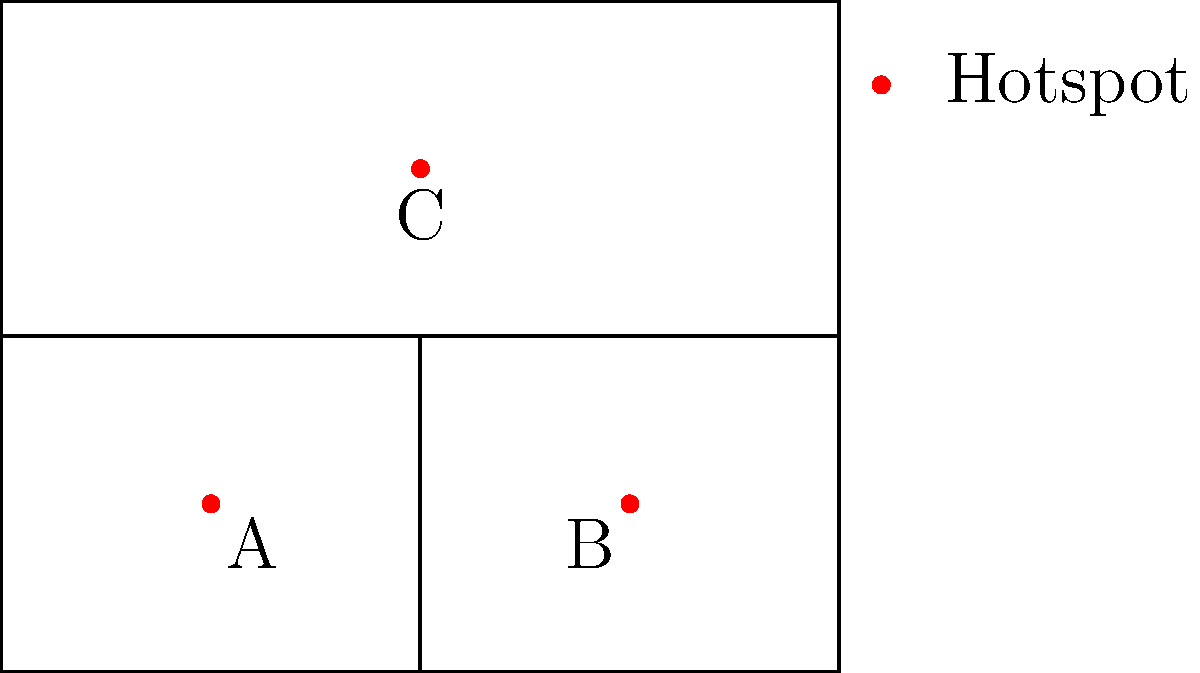Based on the floor plan of a haunted location with marked hotspots, which room contains the most paranormal activity hotspots, and what strategy would you recommend for investigating this area? To answer this question, let's analyze the floor plan step-by-step:

1. The floor plan shows three distinct rooms:
   - Room 1: Bottom left
   - Room 2: Bottom right
   - Room 3: Entire top half

2. Hotspots are marked with red dots and labeled A, B, and C.

3. Counting hotspots in each room:
   - Room 1: 1 hotspot (A)
   - Room 2: 1 hotspot (B)
   - Room 3: 1 hotspot (C)

4. Room 3 is the largest and contains the same number of hotspots as the other rooms, making it the most significant area for investigation.

5. Strategy for investigating Room 3:
   a) Start with a thorough baseline sweep of the entire room.
   b) Focus on the area around hotspot C, as it's centrally located.
   c) Use EMF meters, infrared cameras, and audio recorders to capture potential paranormal activity.
   d) Conduct EVP (Electronic Voice Phenomenon) sessions near hotspot C.
   e) Set up static cameras to monitor the entire room, with emphasis on the hotspot area.
   f) Periodically check the other rooms' hotspots (A and B) for any connected activity.

This strategy allows for a comprehensive investigation of the most active room while still maintaining awareness of the other hotspots in the location.
Answer: Room 3; Thorough baseline sweep, focus on central hotspot C, use various equipment, conduct EVP sessions, set up static cameras, and periodically check other hotspots. 